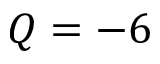<formula> <loc_0><loc_0><loc_500><loc_500>Q = - 6</formula> 